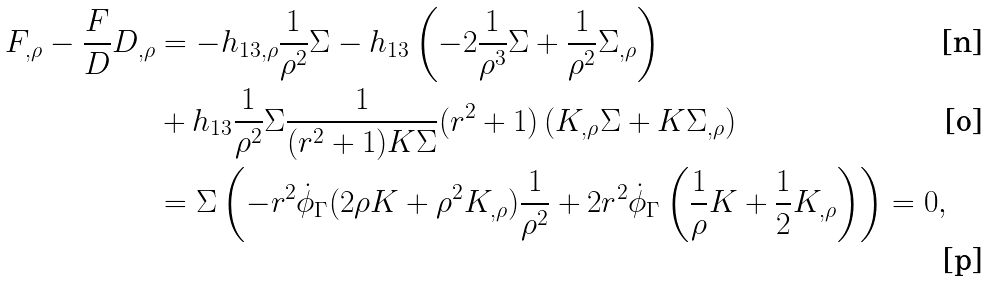Convert formula to latex. <formula><loc_0><loc_0><loc_500><loc_500>F _ { , \rho } - \frac { F } { D } D _ { , \rho } & = - h _ { 1 3 , \rho } \frac { 1 } { \rho ^ { 2 } } \Sigma - h _ { 1 3 } \left ( - 2 \frac { 1 } { \rho ^ { 3 } } \Sigma + \frac { 1 } { \rho ^ { 2 } } \Sigma _ { , \rho } \right ) \\ & + h _ { 1 3 } \frac { 1 } { \rho ^ { 2 } } \Sigma \frac { 1 } { ( r ^ { 2 } + 1 ) K \Sigma } ( r ^ { 2 } + 1 ) \left ( K _ { , \rho } \Sigma + K \Sigma _ { , \rho } \right ) \\ & = \Sigma \left ( - r ^ { 2 } \dot { \phi } _ { \Gamma } ( 2 \rho K + \rho ^ { 2 } K _ { , \rho } ) \frac { 1 } { \rho ^ { 2 } } + 2 r ^ { 2 } \dot { \phi } _ { \Gamma } \left ( \frac { 1 } { \rho } K + \frac { 1 } { 2 } K _ { , \rho } \right ) \right ) = 0 ,</formula> 